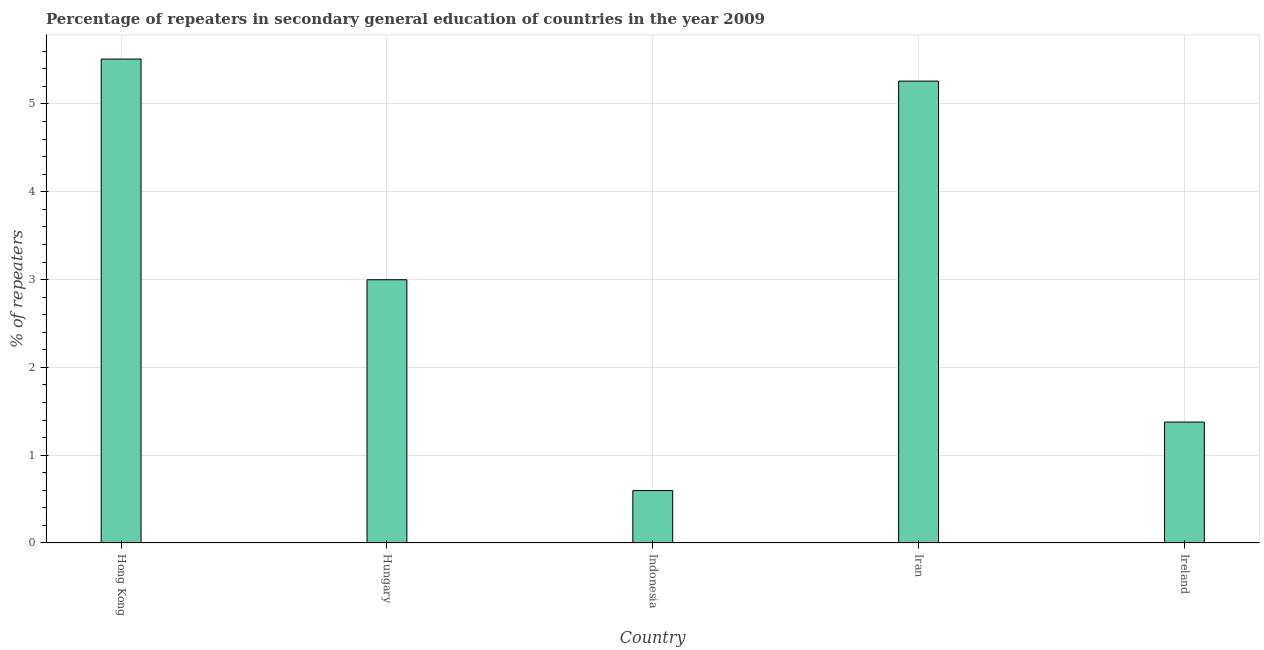Does the graph contain any zero values?
Your response must be concise. No. What is the title of the graph?
Keep it short and to the point. Percentage of repeaters in secondary general education of countries in the year 2009. What is the label or title of the Y-axis?
Provide a succinct answer. % of repeaters. What is the percentage of repeaters in Hungary?
Your answer should be compact. 3. Across all countries, what is the maximum percentage of repeaters?
Keep it short and to the point. 5.51. Across all countries, what is the minimum percentage of repeaters?
Provide a short and direct response. 0.6. In which country was the percentage of repeaters maximum?
Give a very brief answer. Hong Kong. In which country was the percentage of repeaters minimum?
Your answer should be very brief. Indonesia. What is the sum of the percentage of repeaters?
Offer a very short reply. 15.74. What is the difference between the percentage of repeaters in Hong Kong and Iran?
Make the answer very short. 0.25. What is the average percentage of repeaters per country?
Your answer should be very brief. 3.15. What is the median percentage of repeaters?
Your response must be concise. 3. What is the ratio of the percentage of repeaters in Hungary to that in Iran?
Provide a succinct answer. 0.57. What is the difference between the highest and the second highest percentage of repeaters?
Give a very brief answer. 0.25. What is the difference between the highest and the lowest percentage of repeaters?
Your answer should be compact. 4.91. In how many countries, is the percentage of repeaters greater than the average percentage of repeaters taken over all countries?
Your answer should be compact. 2. How many bars are there?
Provide a succinct answer. 5. Are the values on the major ticks of Y-axis written in scientific E-notation?
Give a very brief answer. No. What is the % of repeaters in Hong Kong?
Offer a terse response. 5.51. What is the % of repeaters in Hungary?
Your answer should be very brief. 3. What is the % of repeaters in Indonesia?
Your answer should be compact. 0.6. What is the % of repeaters in Iran?
Provide a short and direct response. 5.26. What is the % of repeaters in Ireland?
Your answer should be very brief. 1.38. What is the difference between the % of repeaters in Hong Kong and Hungary?
Make the answer very short. 2.51. What is the difference between the % of repeaters in Hong Kong and Indonesia?
Make the answer very short. 4.91. What is the difference between the % of repeaters in Hong Kong and Iran?
Provide a succinct answer. 0.25. What is the difference between the % of repeaters in Hong Kong and Ireland?
Give a very brief answer. 4.13. What is the difference between the % of repeaters in Hungary and Indonesia?
Offer a very short reply. 2.4. What is the difference between the % of repeaters in Hungary and Iran?
Offer a terse response. -2.26. What is the difference between the % of repeaters in Hungary and Ireland?
Your response must be concise. 1.62. What is the difference between the % of repeaters in Indonesia and Iran?
Offer a terse response. -4.66. What is the difference between the % of repeaters in Indonesia and Ireland?
Your answer should be very brief. -0.78. What is the difference between the % of repeaters in Iran and Ireland?
Provide a succinct answer. 3.88. What is the ratio of the % of repeaters in Hong Kong to that in Hungary?
Your answer should be compact. 1.84. What is the ratio of the % of repeaters in Hong Kong to that in Indonesia?
Make the answer very short. 9.23. What is the ratio of the % of repeaters in Hong Kong to that in Iran?
Your answer should be very brief. 1.05. What is the ratio of the % of repeaters in Hong Kong to that in Ireland?
Make the answer very short. 4. What is the ratio of the % of repeaters in Hungary to that in Indonesia?
Make the answer very short. 5.02. What is the ratio of the % of repeaters in Hungary to that in Iran?
Make the answer very short. 0.57. What is the ratio of the % of repeaters in Hungary to that in Ireland?
Ensure brevity in your answer.  2.18. What is the ratio of the % of repeaters in Indonesia to that in Iran?
Offer a very short reply. 0.11. What is the ratio of the % of repeaters in Indonesia to that in Ireland?
Your response must be concise. 0.43. What is the ratio of the % of repeaters in Iran to that in Ireland?
Give a very brief answer. 3.82. 